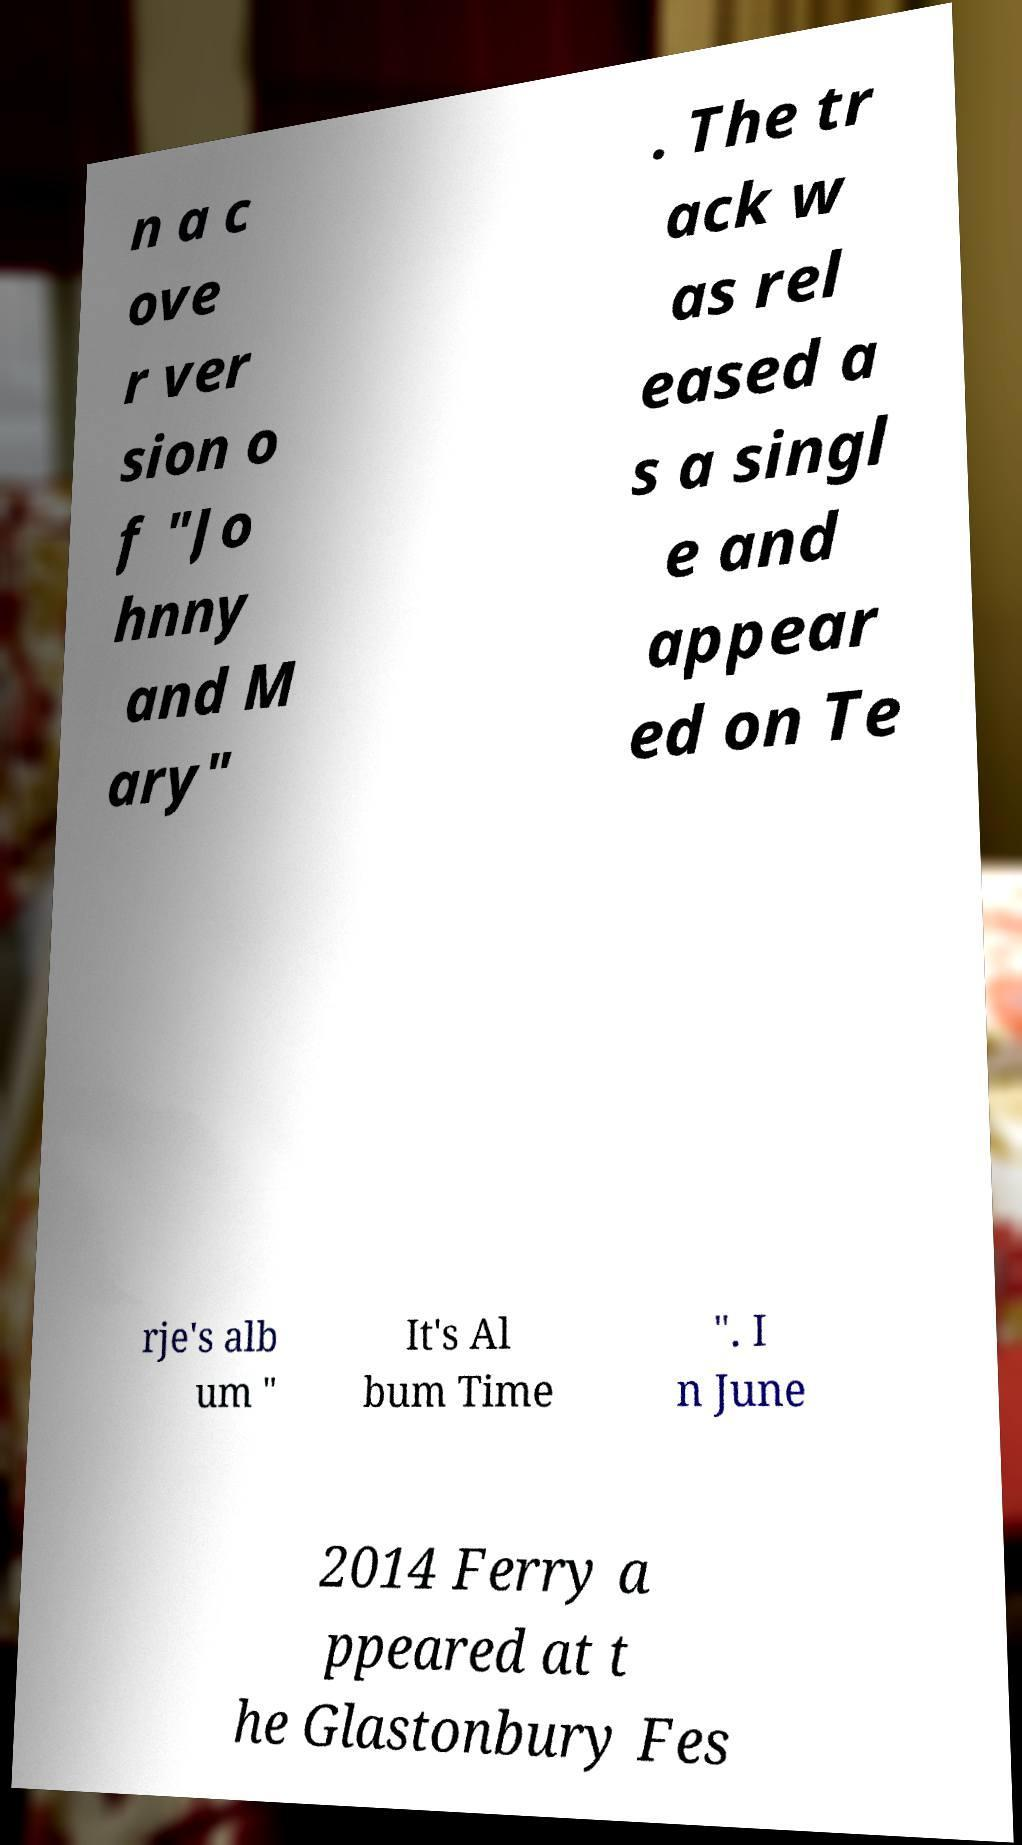Can you accurately transcribe the text from the provided image for me? n a c ove r ver sion o f "Jo hnny and M ary" . The tr ack w as rel eased a s a singl e and appear ed on Te rje's alb um " It's Al bum Time ". I n June 2014 Ferry a ppeared at t he Glastonbury Fes 